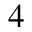<formula> <loc_0><loc_0><loc_500><loc_500>{ 4 }</formula> 